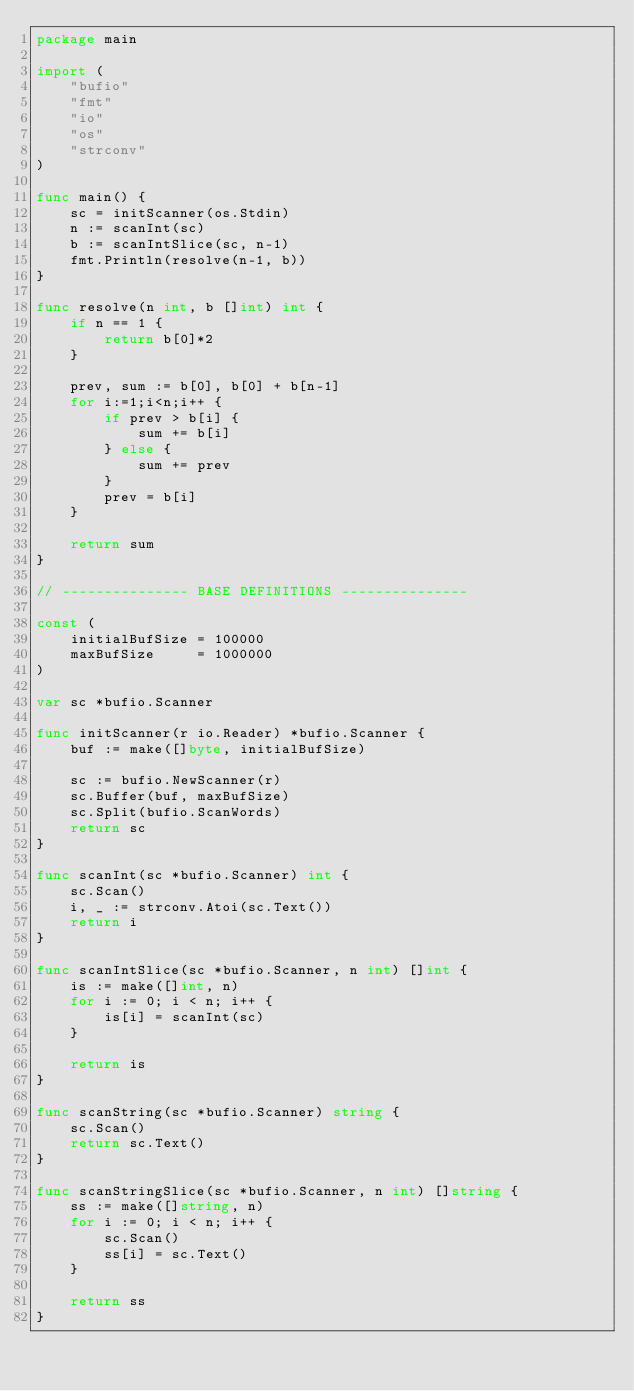<code> <loc_0><loc_0><loc_500><loc_500><_Go_>package main

import (
	"bufio"
	"fmt"
	"io"
	"os"
	"strconv"
)

func main() {
	sc = initScanner(os.Stdin)
	n := scanInt(sc)
	b := scanIntSlice(sc, n-1)
	fmt.Println(resolve(n-1, b))
}

func resolve(n int, b []int) int {
	if n == 1 {
		return b[0]*2
	}

	prev, sum := b[0], b[0] + b[n-1]
	for i:=1;i<n;i++ {
		if prev > b[i] {
			sum += b[i]
		} else {
			sum += prev
		}
		prev = b[i]
	}

	return sum
}

// --------------- BASE DEFINITIONS ---------------

const (
	initialBufSize = 100000
	maxBufSize     = 1000000
)

var sc *bufio.Scanner

func initScanner(r io.Reader) *bufio.Scanner {
	buf := make([]byte, initialBufSize)

	sc := bufio.NewScanner(r)
	sc.Buffer(buf, maxBufSize)
	sc.Split(bufio.ScanWords)
	return sc
}

func scanInt(sc *bufio.Scanner) int {
	sc.Scan()
	i, _ := strconv.Atoi(sc.Text())
	return i
}

func scanIntSlice(sc *bufio.Scanner, n int) []int {
	is := make([]int, n)
	for i := 0; i < n; i++ {
		is[i] = scanInt(sc)
	}

	return is
}

func scanString(sc *bufio.Scanner) string {
	sc.Scan()
	return sc.Text()
}

func scanStringSlice(sc *bufio.Scanner, n int) []string {
	ss := make([]string, n)
	for i := 0; i < n; i++ {
		sc.Scan()
		ss[i] = sc.Text()
	}

	return ss
}
</code> 